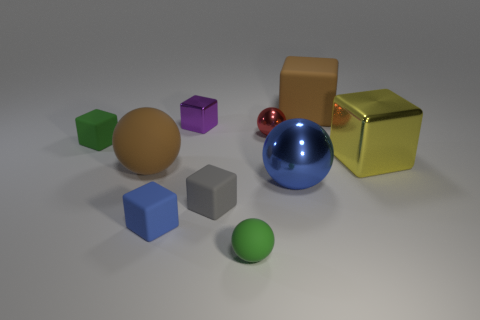There is a big thing that is the same color as the big rubber block; what material is it?
Keep it short and to the point. Rubber. What color is the other small metallic object that is the same shape as the gray thing?
Your response must be concise. Purple. There is a yellow object; is its shape the same as the tiny metallic thing left of the tiny red object?
Provide a succinct answer. Yes. How many other objects are the same material as the small green cube?
Your answer should be very brief. 5. There is a small rubber ball; is it the same color as the tiny matte object that is behind the tiny gray matte cube?
Give a very brief answer. Yes. What material is the cube that is right of the brown matte block?
Your answer should be very brief. Metal. Are there any big objects that have the same color as the big metal sphere?
Offer a very short reply. No. There is a shiny ball that is the same size as the purple thing; what color is it?
Give a very brief answer. Red. What number of tiny objects are blue metallic balls or green objects?
Provide a short and direct response. 2. Are there the same number of tiny blue things on the left side of the large brown rubber ball and large brown matte objects that are in front of the large matte block?
Keep it short and to the point. No. 